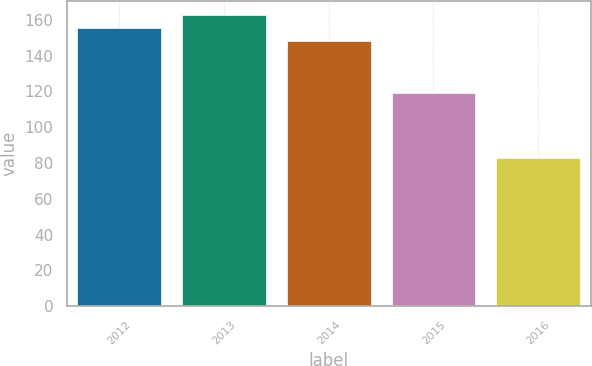Convert chart to OTSL. <chart><loc_0><loc_0><loc_500><loc_500><bar_chart><fcel>2012<fcel>2013<fcel>2014<fcel>2015<fcel>2016<nl><fcel>155.2<fcel>162.4<fcel>148<fcel>119<fcel>83<nl></chart> 